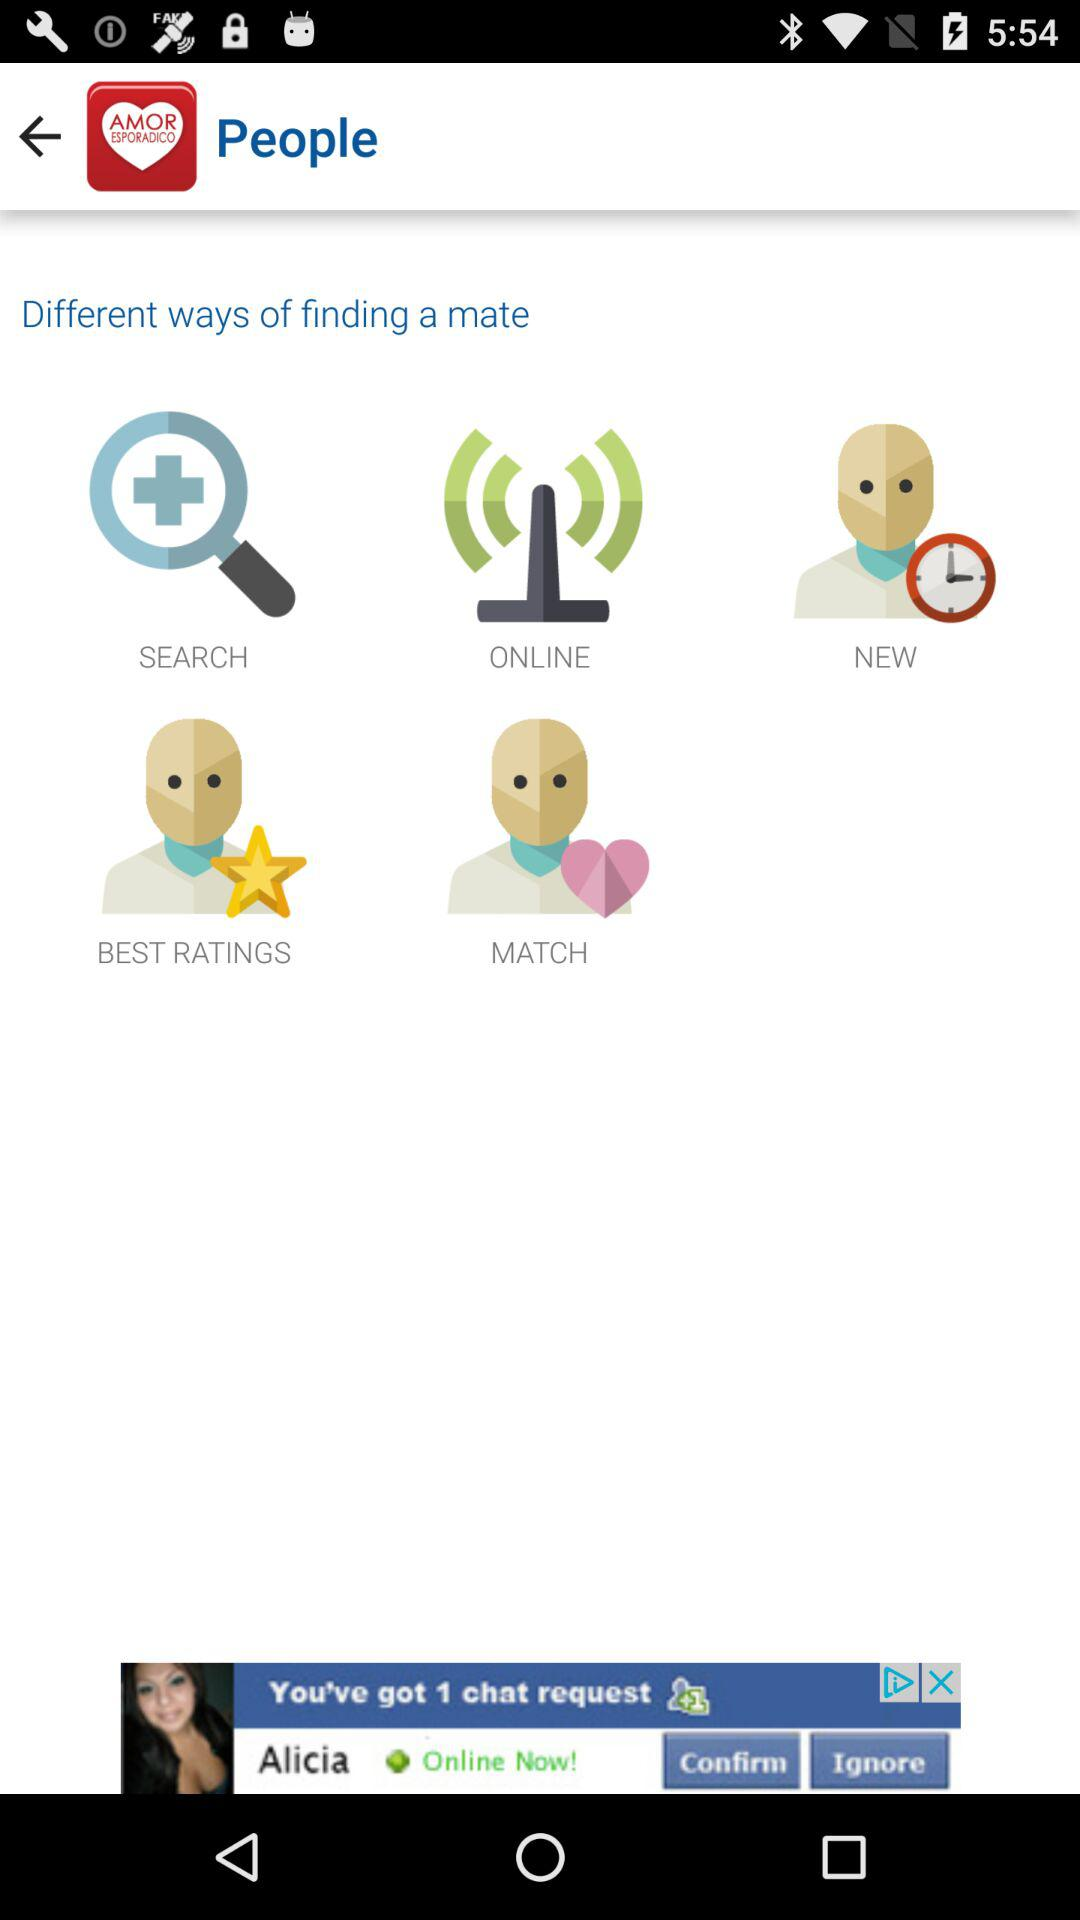What are the different ways of finding a mate? The different ways of finding a mate are: "SCREEN", "ONLINE", "NEW", "BEST RATINGS", and "MATCH". 